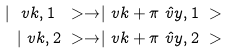<formula> <loc_0><loc_0><loc_500><loc_500>| \ v k , 1 \ > \to & | \ v k + \pi \hat { \ v y } , 1 \ > \\ | \ v k , 2 \ > \to & | \ v k + \pi \hat { \ v y } , 2 \ ></formula> 